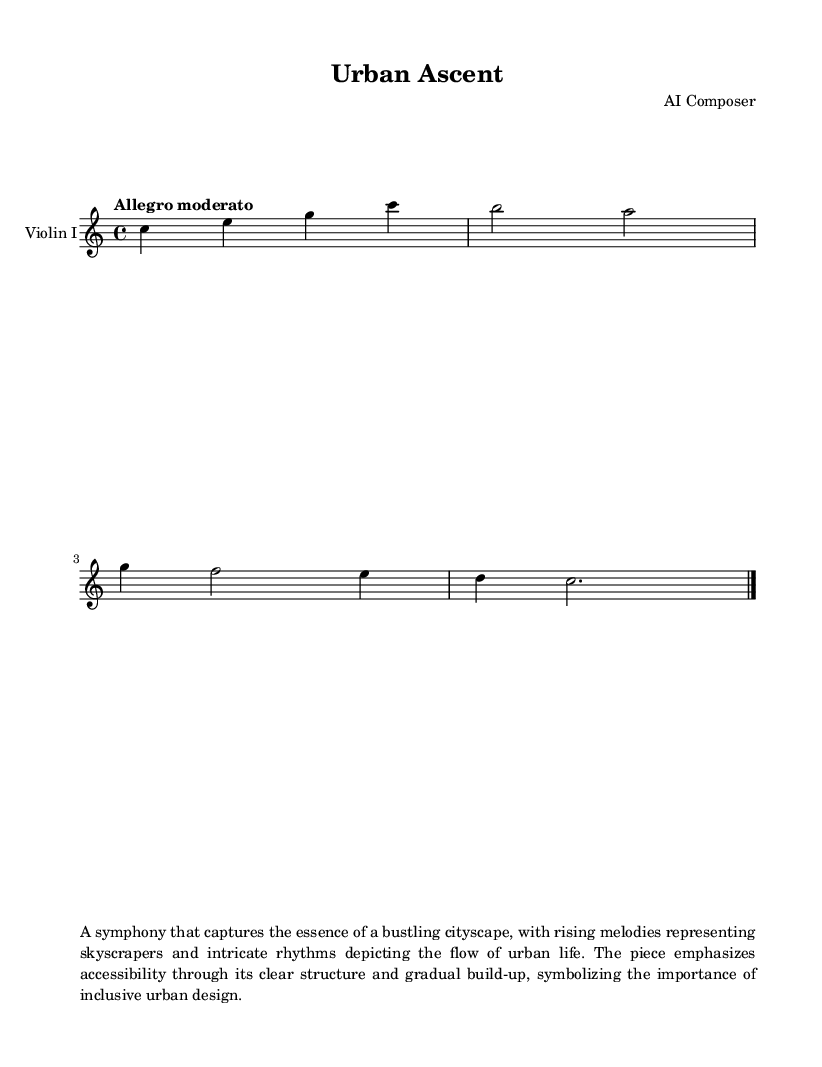What is the key signature of this music? The key signature is determined by looking at the beginning of the staff where sharps or flats are indicated. In this case, it shows no sharps or flats, which means it is in C major.
Answer: C major What is the time signature of this music? The time signature can be found at the beginning of the score, noted as a fraction. Here, it shows 4/4, which means there are four beats in each measure and the quarter note gets one beat.
Answer: 4/4 What is the tempo marking of this music? The tempo marking is indicated by the word following the \tempo command. In this music, it states "Allegro moderato," which refers to a moderately fast pace.
Answer: Allegro moderato How many measures are in the music? To find the number of measures, count the bar lines indicated in the score. Since there is one bar line at the end, and measures are separated by these lines, there is one measure total in the piece presented.
Answer: 1 What instrument is specified for this symphony? The instrument is listed in the new Staff section of the score. It is clearly labeled as "Violin I," indicating that this part is written for the first violin.
Answer: Violin I What does the music symbolize in terms of urban design? The description in the markup states the piece emphasizes accessibility and symbolizes inclusive urban design through its structure and progression. This is reflective of the theme of architectural marvels in urban landscapes.
Answer: Inclusive urban design 